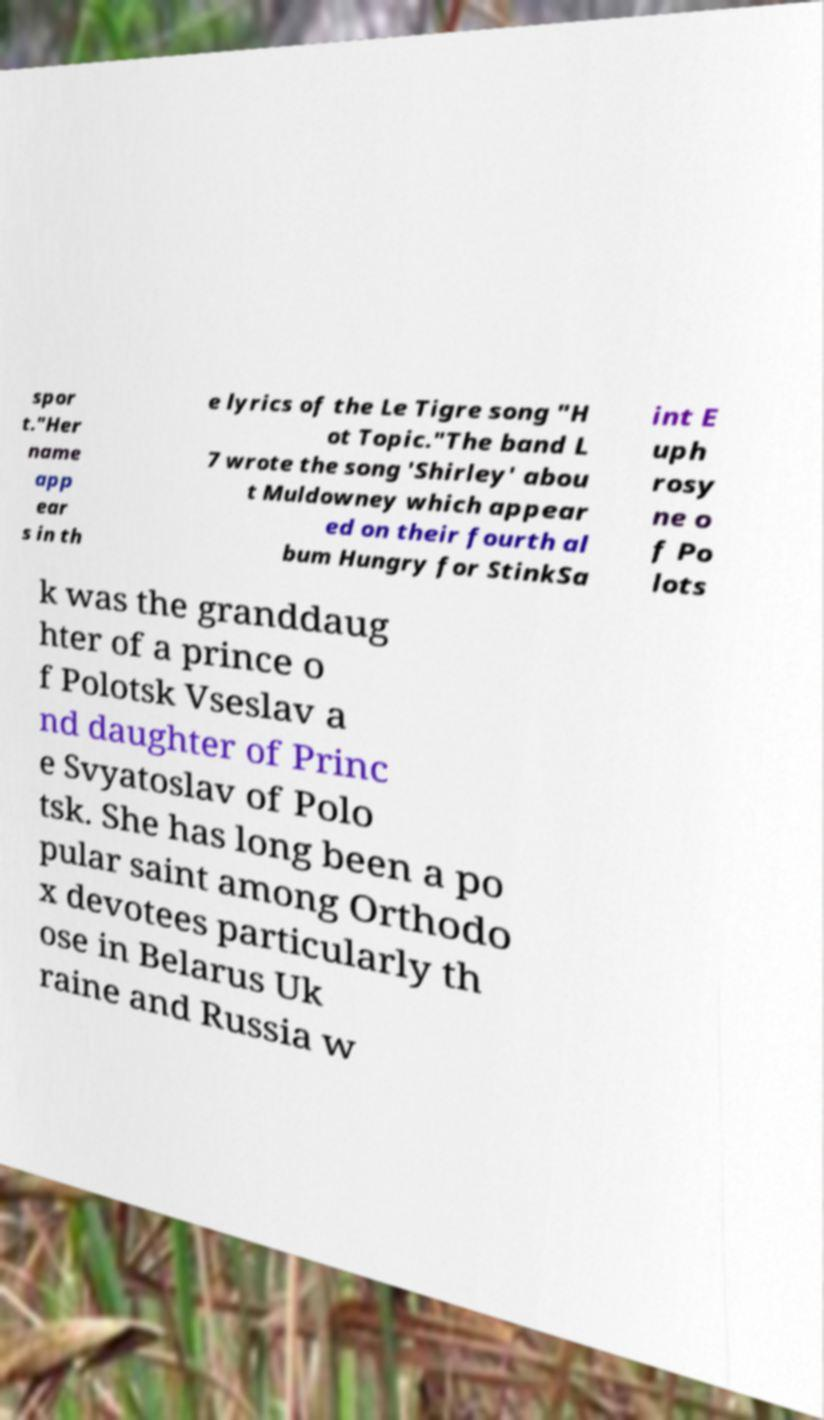Can you read and provide the text displayed in the image?This photo seems to have some interesting text. Can you extract and type it out for me? spor t."Her name app ear s in th e lyrics of the Le Tigre song "H ot Topic."The band L 7 wrote the song 'Shirley' abou t Muldowney which appear ed on their fourth al bum Hungry for StinkSa int E uph rosy ne o f Po lots k was the granddaug hter of a prince o f Polotsk Vseslav a nd daughter of Princ e Svyatoslav of Polo tsk. She has long been a po pular saint among Orthodo x devotees particularly th ose in Belarus Uk raine and Russia w 